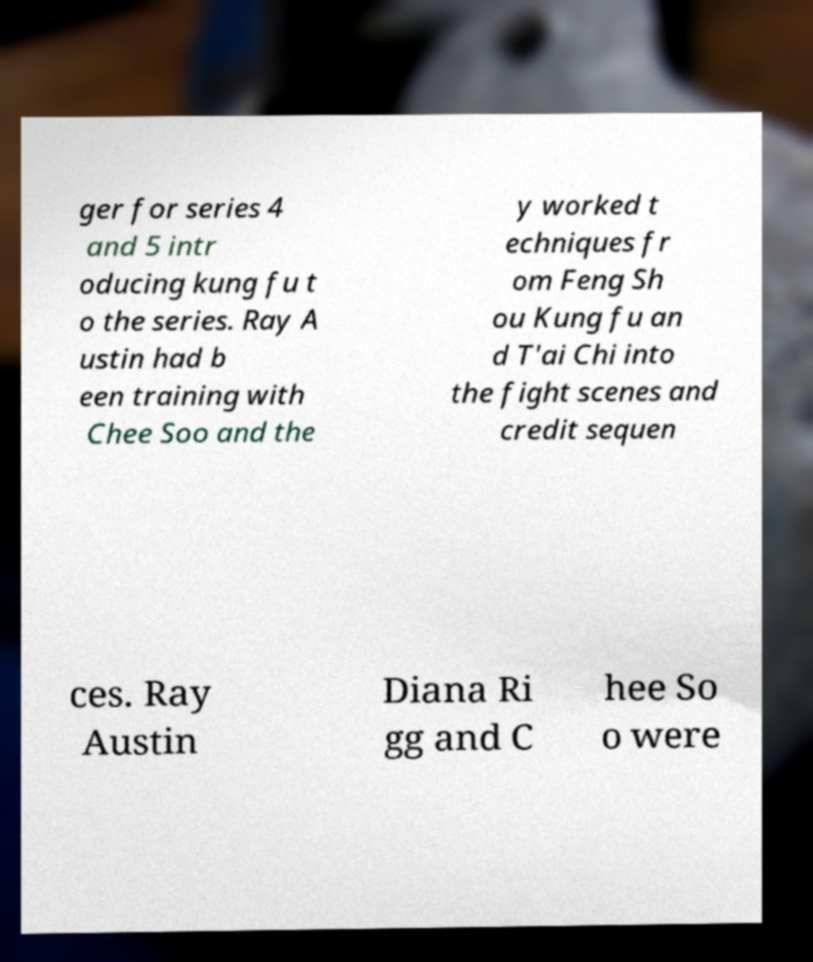What messages or text are displayed in this image? I need them in a readable, typed format. ger for series 4 and 5 intr oducing kung fu t o the series. Ray A ustin had b een training with Chee Soo and the y worked t echniques fr om Feng Sh ou Kung fu an d T'ai Chi into the fight scenes and credit sequen ces. Ray Austin Diana Ri gg and C hee So o were 